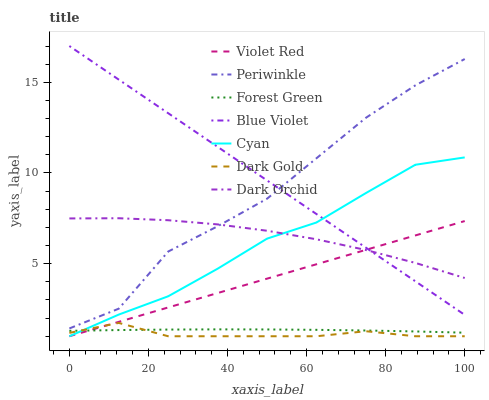Does Dark Gold have the minimum area under the curve?
Answer yes or no. Yes. Does Blue Violet have the maximum area under the curve?
Answer yes or no. Yes. Does Dark Orchid have the minimum area under the curve?
Answer yes or no. No. Does Dark Orchid have the maximum area under the curve?
Answer yes or no. No. Is Violet Red the smoothest?
Answer yes or no. Yes. Is Periwinkle the roughest?
Answer yes or no. Yes. Is Dark Gold the smoothest?
Answer yes or no. No. Is Dark Gold the roughest?
Answer yes or no. No. Does Violet Red have the lowest value?
Answer yes or no. Yes. Does Dark Orchid have the lowest value?
Answer yes or no. No. Does Blue Violet have the highest value?
Answer yes or no. Yes. Does Dark Gold have the highest value?
Answer yes or no. No. Is Forest Green less than Periwinkle?
Answer yes or no. Yes. Is Periwinkle greater than Dark Gold?
Answer yes or no. Yes. Does Dark Orchid intersect Violet Red?
Answer yes or no. Yes. Is Dark Orchid less than Violet Red?
Answer yes or no. No. Is Dark Orchid greater than Violet Red?
Answer yes or no. No. Does Forest Green intersect Periwinkle?
Answer yes or no. No. 